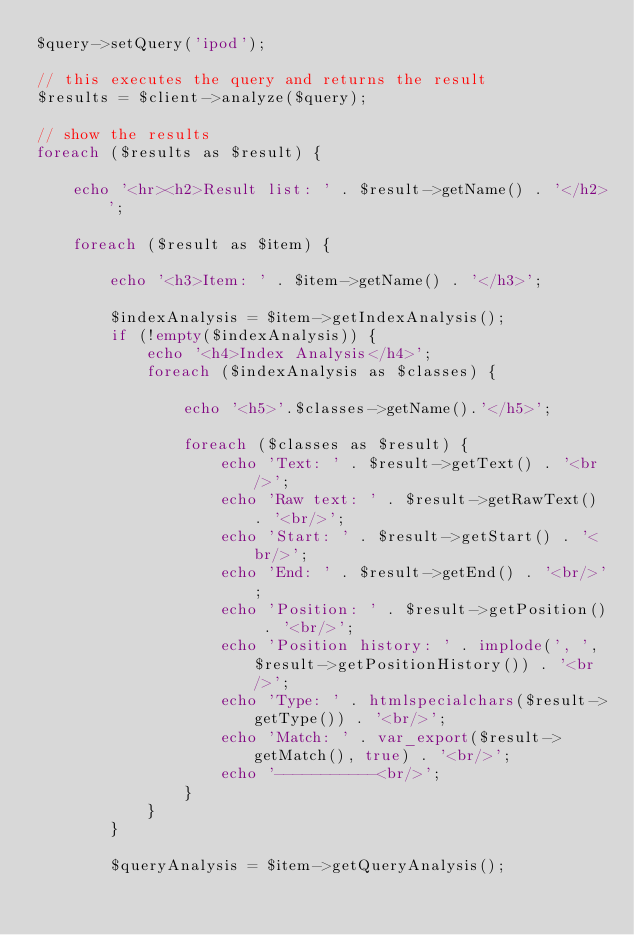Convert code to text. <code><loc_0><loc_0><loc_500><loc_500><_PHP_>$query->setQuery('ipod');

// this executes the query and returns the result
$results = $client->analyze($query);

// show the results
foreach ($results as $result) {

    echo '<hr><h2>Result list: ' . $result->getName() . '</h2>';

    foreach ($result as $item) {

        echo '<h3>Item: ' . $item->getName() . '</h3>';

        $indexAnalysis = $item->getIndexAnalysis();
        if (!empty($indexAnalysis)) {
            echo '<h4>Index Analysis</h4>';
            foreach ($indexAnalysis as $classes) {

                echo '<h5>'.$classes->getName().'</h5>';

                foreach ($classes as $result) {
                    echo 'Text: ' . $result->getText() . '<br/>';
                    echo 'Raw text: ' . $result->getRawText() . '<br/>';
                    echo 'Start: ' . $result->getStart() . '<br/>';
                    echo 'End: ' . $result->getEnd() . '<br/>';
                    echo 'Position: ' . $result->getPosition() . '<br/>';
                    echo 'Position history: ' . implode(', ', $result->getPositionHistory()) . '<br/>';
                    echo 'Type: ' . htmlspecialchars($result->getType()) . '<br/>';
                    echo 'Match: ' . var_export($result->getMatch(), true) . '<br/>';
                    echo '-----------<br/>';
                }
            }
        }

        $queryAnalysis = $item->getQueryAnalysis();</code> 